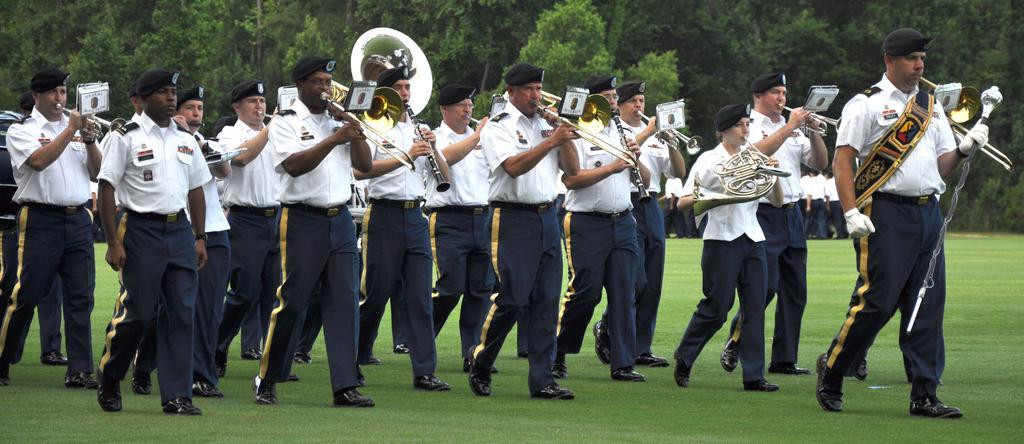Can you describe this image briefly? In the center of the image a group of people are walking and wearing a hat. And some of them are holding a musical instruments in their hand. In the background of the image we can see trees are present. At the bottom of the image grass is present. 